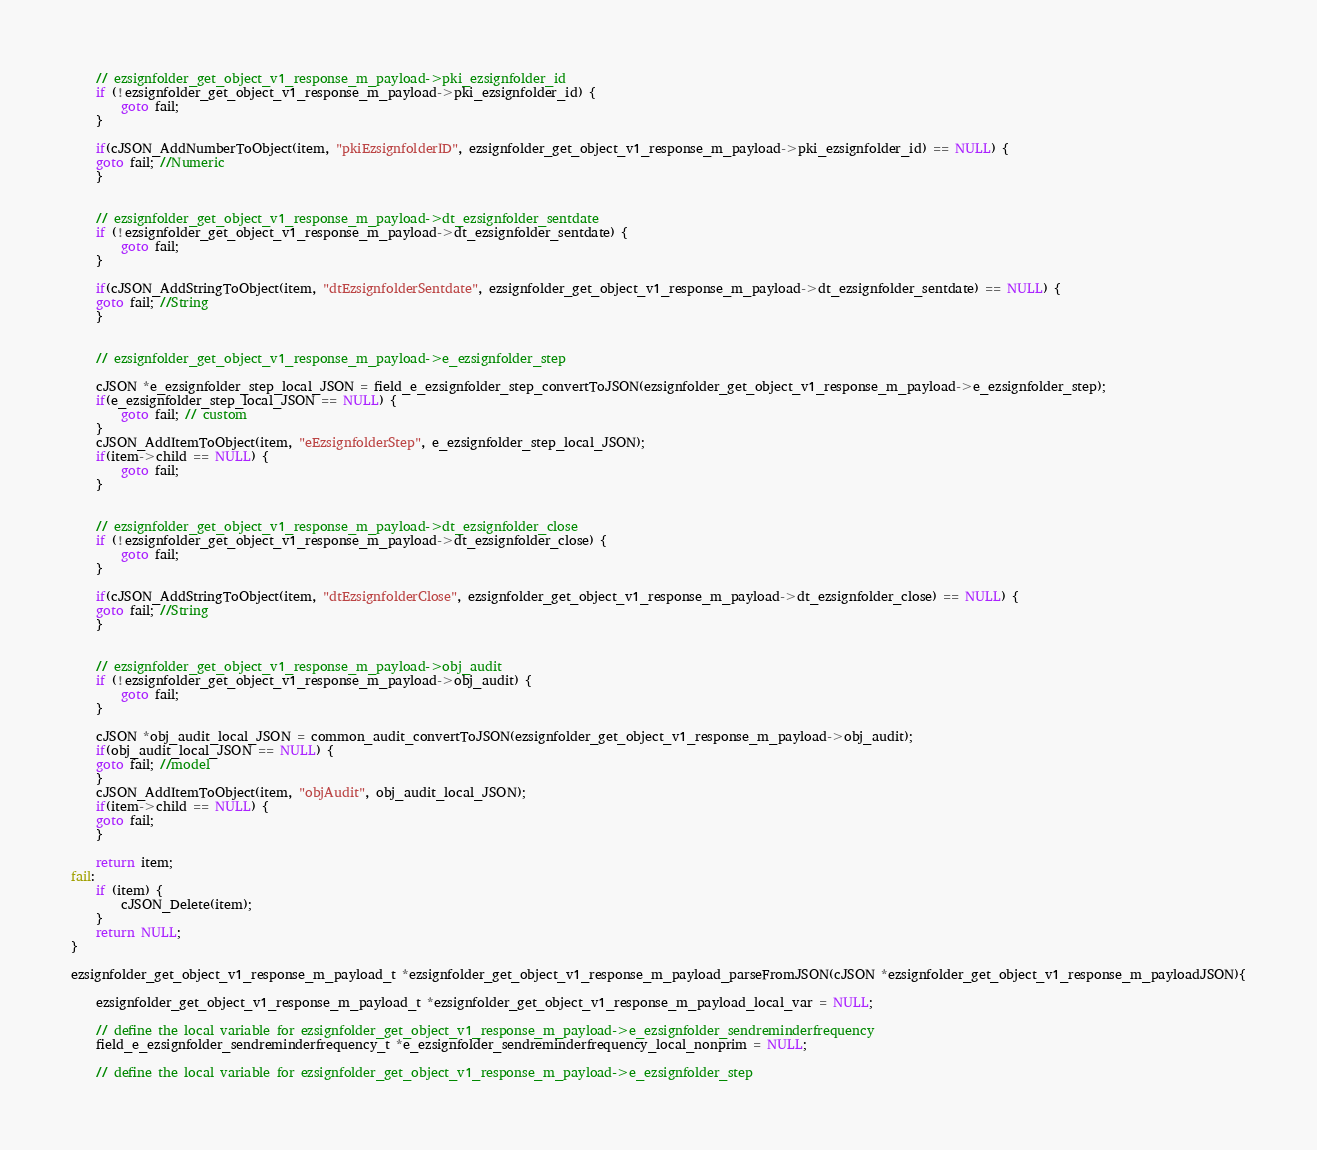Convert code to text. <code><loc_0><loc_0><loc_500><loc_500><_C_>
    // ezsignfolder_get_object_v1_response_m_payload->pki_ezsignfolder_id
    if (!ezsignfolder_get_object_v1_response_m_payload->pki_ezsignfolder_id) {
        goto fail;
    }
    
    if(cJSON_AddNumberToObject(item, "pkiEzsignfolderID", ezsignfolder_get_object_v1_response_m_payload->pki_ezsignfolder_id) == NULL) {
    goto fail; //Numeric
    }


    // ezsignfolder_get_object_v1_response_m_payload->dt_ezsignfolder_sentdate
    if (!ezsignfolder_get_object_v1_response_m_payload->dt_ezsignfolder_sentdate) {
        goto fail;
    }
    
    if(cJSON_AddStringToObject(item, "dtEzsignfolderSentdate", ezsignfolder_get_object_v1_response_m_payload->dt_ezsignfolder_sentdate) == NULL) {
    goto fail; //String
    }


    // ezsignfolder_get_object_v1_response_m_payload->e_ezsignfolder_step
    
    cJSON *e_ezsignfolder_step_local_JSON = field_e_ezsignfolder_step_convertToJSON(ezsignfolder_get_object_v1_response_m_payload->e_ezsignfolder_step);
    if(e_ezsignfolder_step_local_JSON == NULL) {
        goto fail; // custom
    }
    cJSON_AddItemToObject(item, "eEzsignfolderStep", e_ezsignfolder_step_local_JSON);
    if(item->child == NULL) {
        goto fail;
    }


    // ezsignfolder_get_object_v1_response_m_payload->dt_ezsignfolder_close
    if (!ezsignfolder_get_object_v1_response_m_payload->dt_ezsignfolder_close) {
        goto fail;
    }
    
    if(cJSON_AddStringToObject(item, "dtEzsignfolderClose", ezsignfolder_get_object_v1_response_m_payload->dt_ezsignfolder_close) == NULL) {
    goto fail; //String
    }


    // ezsignfolder_get_object_v1_response_m_payload->obj_audit
    if (!ezsignfolder_get_object_v1_response_m_payload->obj_audit) {
        goto fail;
    }
    
    cJSON *obj_audit_local_JSON = common_audit_convertToJSON(ezsignfolder_get_object_v1_response_m_payload->obj_audit);
    if(obj_audit_local_JSON == NULL) {
    goto fail; //model
    }
    cJSON_AddItemToObject(item, "objAudit", obj_audit_local_JSON);
    if(item->child == NULL) {
    goto fail;
    }

    return item;
fail:
    if (item) {
        cJSON_Delete(item);
    }
    return NULL;
}

ezsignfolder_get_object_v1_response_m_payload_t *ezsignfolder_get_object_v1_response_m_payload_parseFromJSON(cJSON *ezsignfolder_get_object_v1_response_m_payloadJSON){

    ezsignfolder_get_object_v1_response_m_payload_t *ezsignfolder_get_object_v1_response_m_payload_local_var = NULL;

    // define the local variable for ezsignfolder_get_object_v1_response_m_payload->e_ezsignfolder_sendreminderfrequency
    field_e_ezsignfolder_sendreminderfrequency_t *e_ezsignfolder_sendreminderfrequency_local_nonprim = NULL;

    // define the local variable for ezsignfolder_get_object_v1_response_m_payload->e_ezsignfolder_step</code> 